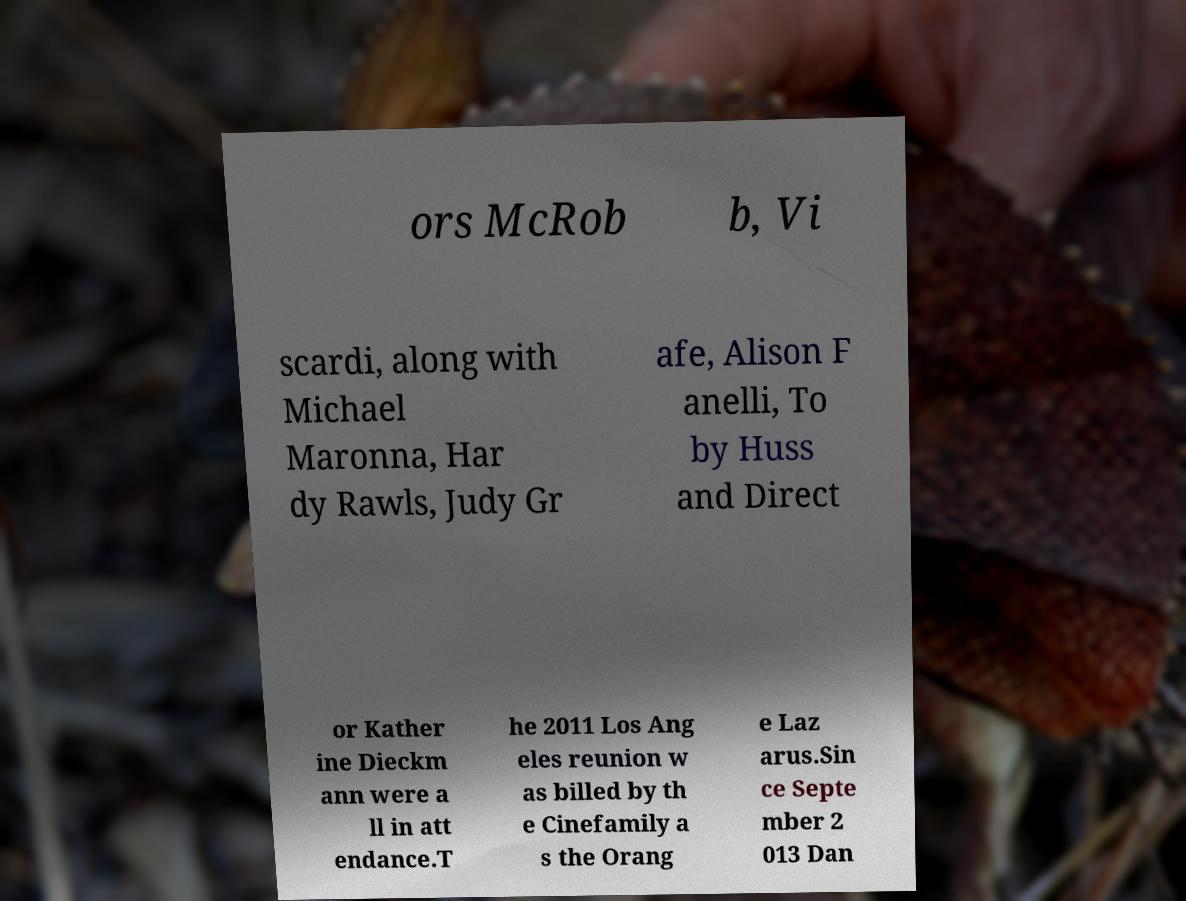I need the written content from this picture converted into text. Can you do that? ors McRob b, Vi scardi, along with Michael Maronna, Har dy Rawls, Judy Gr afe, Alison F anelli, To by Huss and Direct or Kather ine Dieckm ann were a ll in att endance.T he 2011 Los Ang eles reunion w as billed by th e Cinefamily a s the Orang e Laz arus.Sin ce Septe mber 2 013 Dan 